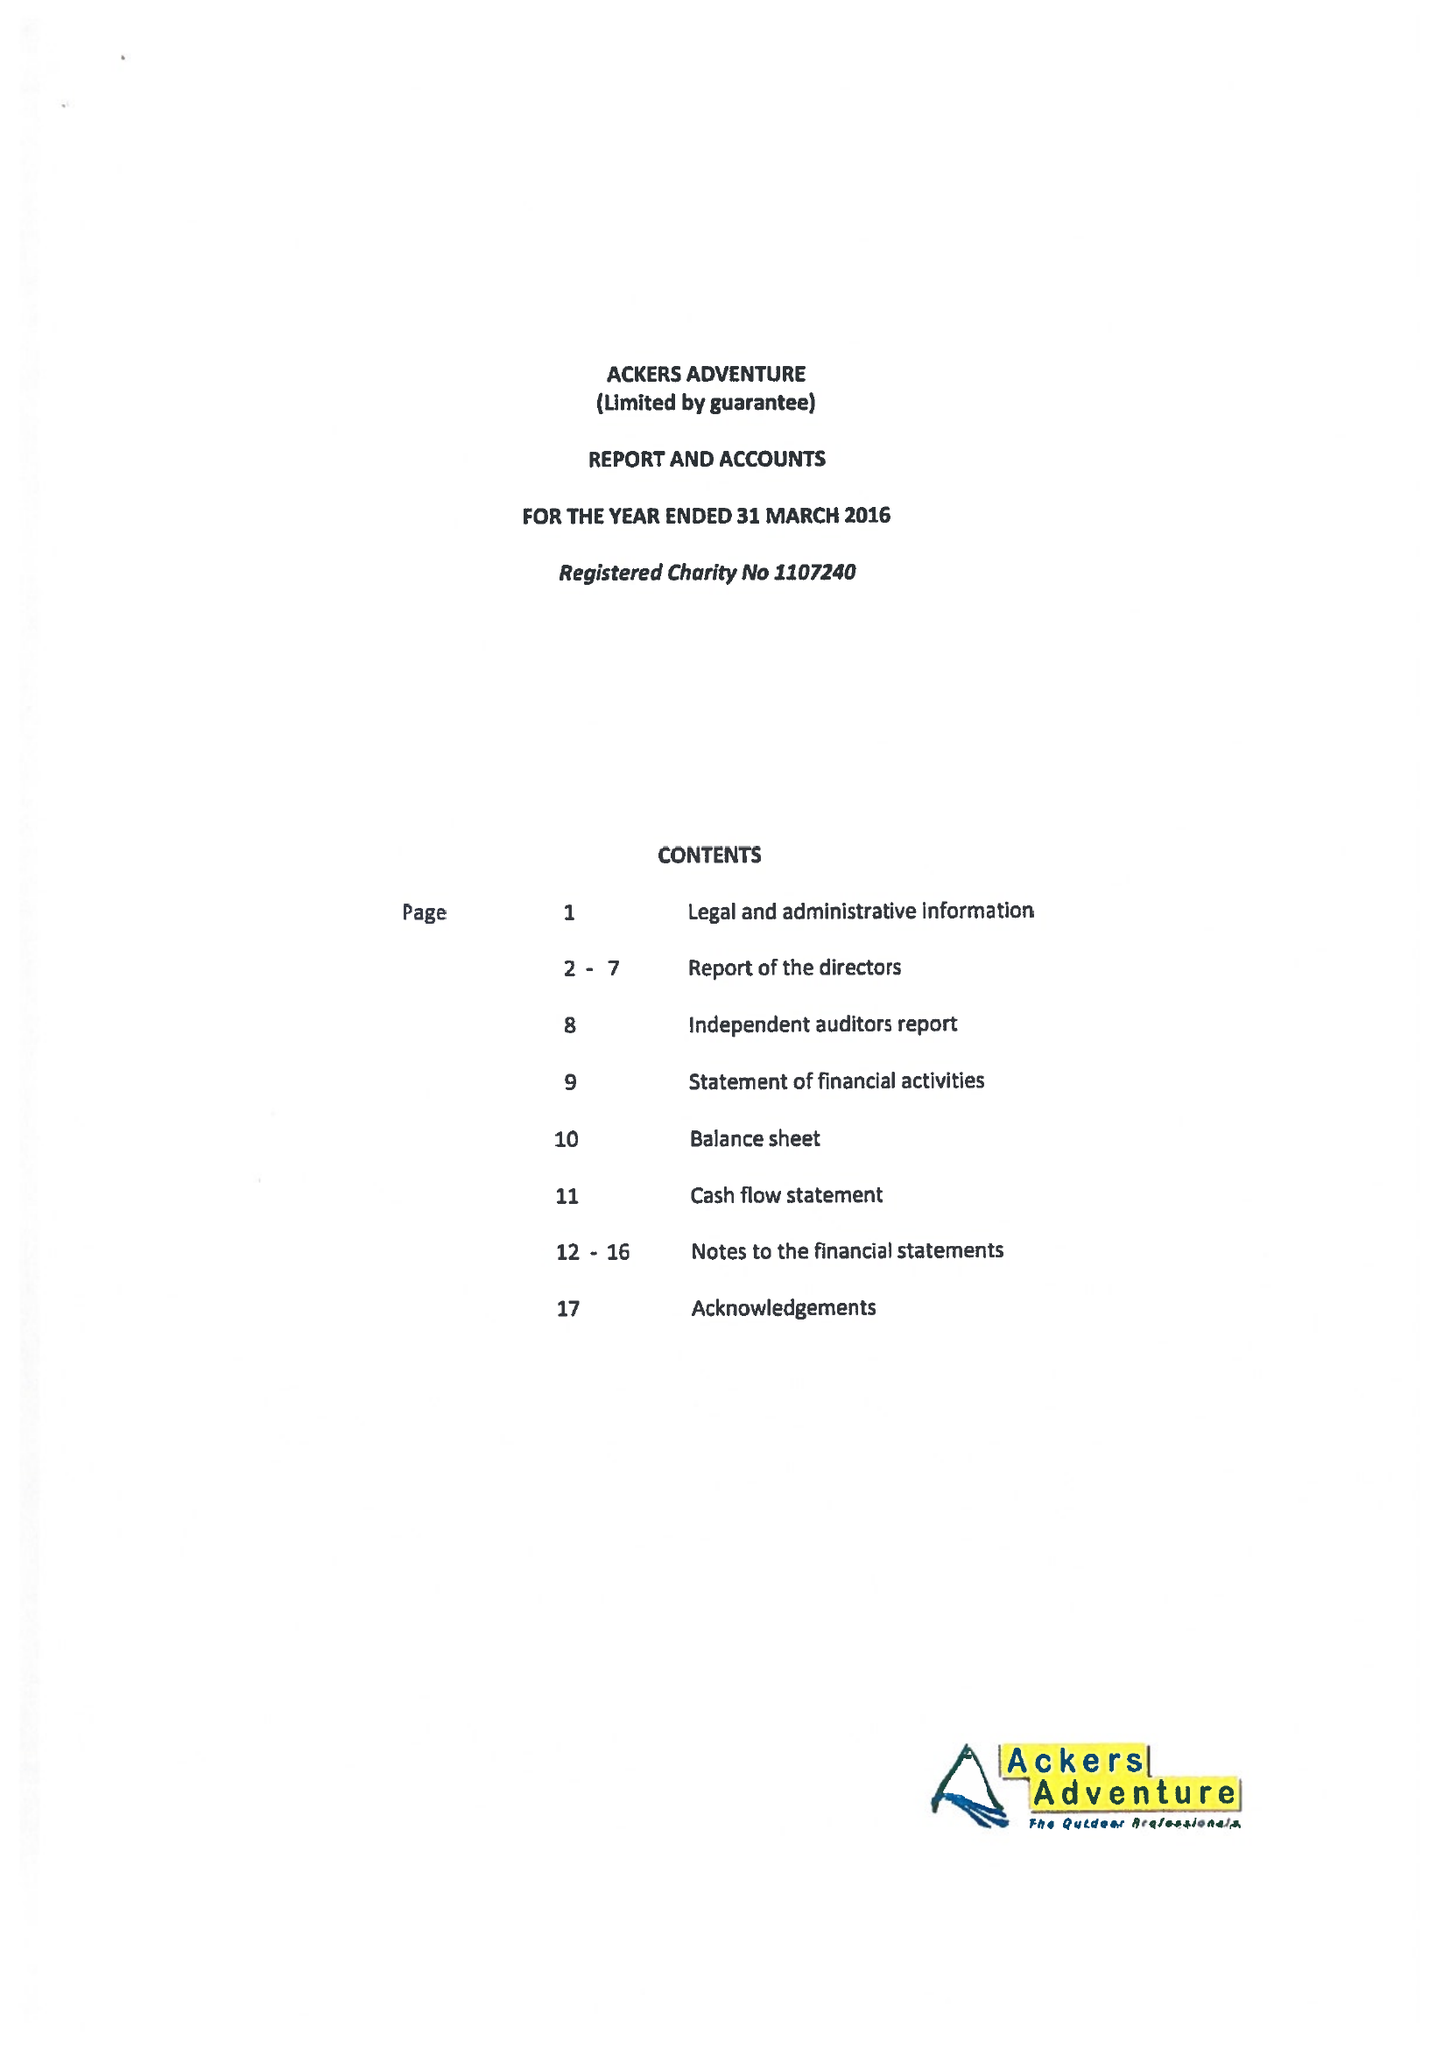What is the value for the income_annually_in_british_pounds?
Answer the question using a single word or phrase. 570420.00 